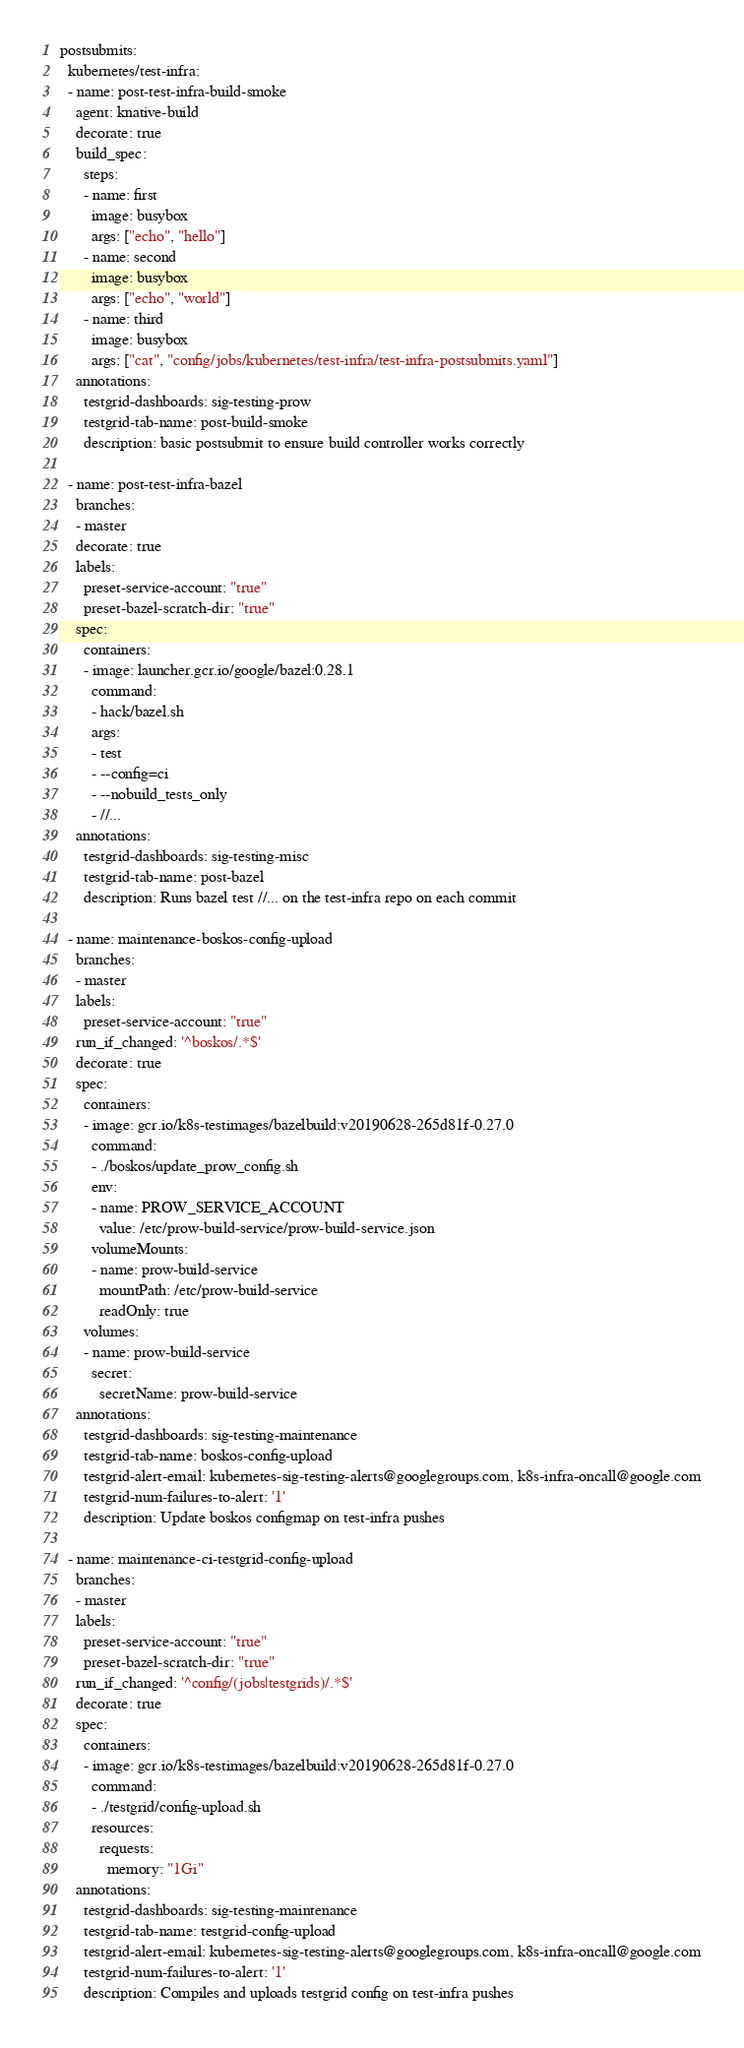<code> <loc_0><loc_0><loc_500><loc_500><_YAML_>postsubmits:
  kubernetes/test-infra:
  - name: post-test-infra-build-smoke
    agent: knative-build
    decorate: true
    build_spec:
      steps:
      - name: first
        image: busybox
        args: ["echo", "hello"]
      - name: second
        image: busybox
        args: ["echo", "world"]
      - name: third
        image: busybox
        args: ["cat", "config/jobs/kubernetes/test-infra/test-infra-postsubmits.yaml"]
    annotations:
      testgrid-dashboards: sig-testing-prow
      testgrid-tab-name: post-build-smoke
      description: basic postsubmit to ensure build controller works correctly

  - name: post-test-infra-bazel
    branches:
    - master
    decorate: true
    labels:
      preset-service-account: "true"
      preset-bazel-scratch-dir: "true"
    spec:
      containers:
      - image: launcher.gcr.io/google/bazel:0.28.1
        command:
        - hack/bazel.sh
        args:
        - test
        - --config=ci
        - --nobuild_tests_only
        - //...
    annotations:
      testgrid-dashboards: sig-testing-misc
      testgrid-tab-name: post-bazel
      description: Runs bazel test //... on the test-infra repo on each commit

  - name: maintenance-boskos-config-upload
    branches:
    - master
    labels:
      preset-service-account: "true"
    run_if_changed: '^boskos/.*$'
    decorate: true
    spec:
      containers:
      - image: gcr.io/k8s-testimages/bazelbuild:v20190628-265d81f-0.27.0
        command:
        - ./boskos/update_prow_config.sh
        env:
        - name: PROW_SERVICE_ACCOUNT
          value: /etc/prow-build-service/prow-build-service.json
        volumeMounts:
        - name: prow-build-service
          mountPath: /etc/prow-build-service
          readOnly: true
      volumes:
      - name: prow-build-service
        secret:
          secretName: prow-build-service
    annotations:
      testgrid-dashboards: sig-testing-maintenance
      testgrid-tab-name: boskos-config-upload
      testgrid-alert-email: kubernetes-sig-testing-alerts@googlegroups.com, k8s-infra-oncall@google.com
      testgrid-num-failures-to-alert: '1'
      description: Update boskos configmap on test-infra pushes

  - name: maintenance-ci-testgrid-config-upload
    branches:
    - master
    labels:
      preset-service-account: "true"
      preset-bazel-scratch-dir: "true"
    run_if_changed: '^config/(jobs|testgrids)/.*$'
    decorate: true
    spec:
      containers:
      - image: gcr.io/k8s-testimages/bazelbuild:v20190628-265d81f-0.27.0
        command:
        - ./testgrid/config-upload.sh
        resources:
          requests:
            memory: "1Gi"
    annotations:
      testgrid-dashboards: sig-testing-maintenance
      testgrid-tab-name: testgrid-config-upload
      testgrid-alert-email: kubernetes-sig-testing-alerts@googlegroups.com, k8s-infra-oncall@google.com
      testgrid-num-failures-to-alert: '1'
      description: Compiles and uploads testgrid config on test-infra pushes
</code> 